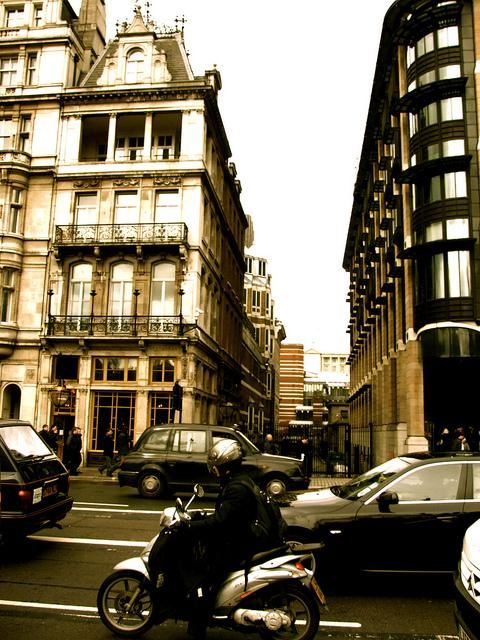How many motorcycles do you see? Please explain your reasoning. one. There is one bike. 